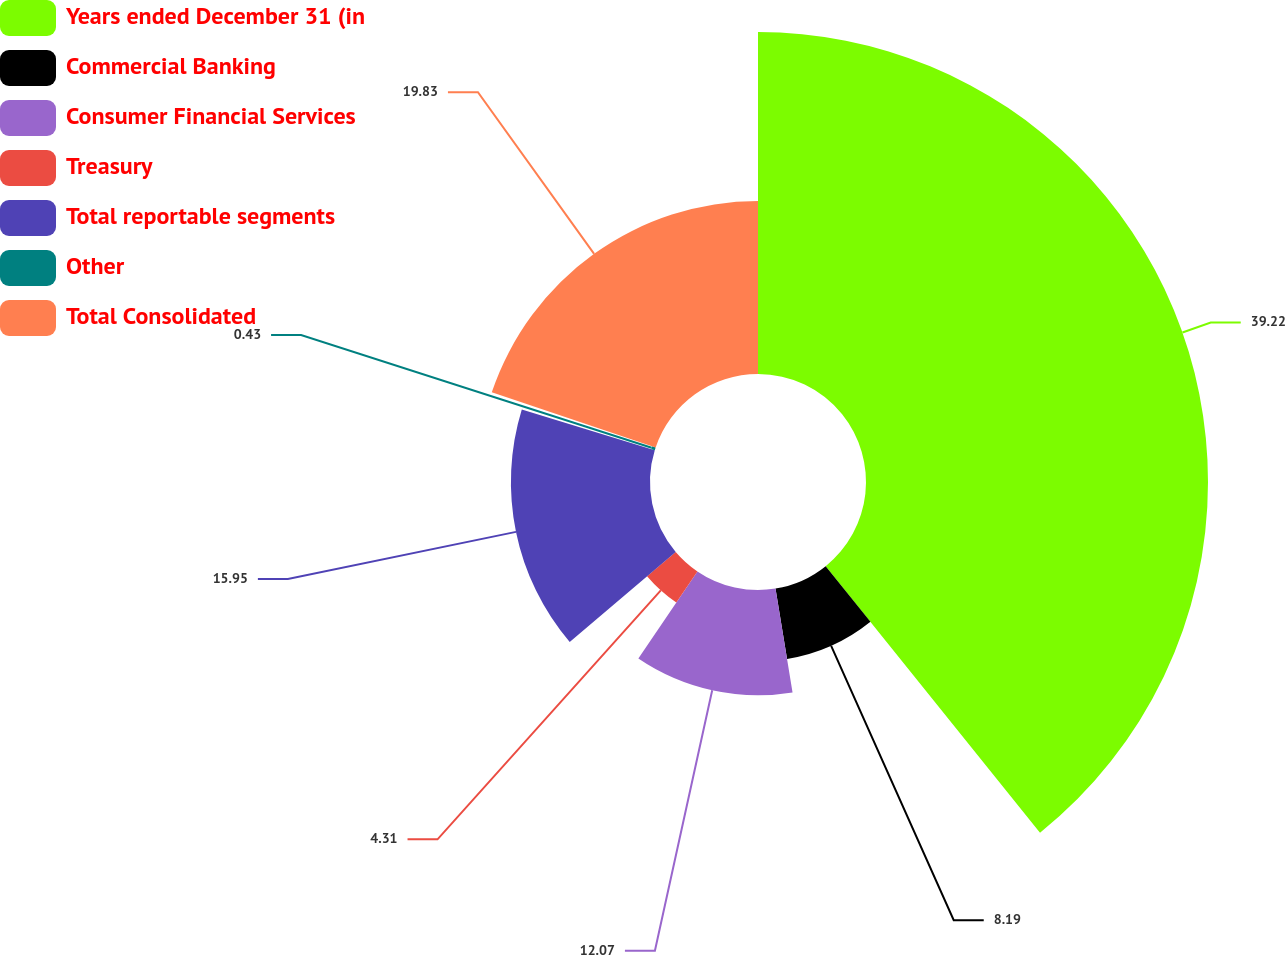Convert chart. <chart><loc_0><loc_0><loc_500><loc_500><pie_chart><fcel>Years ended December 31 (in<fcel>Commercial Banking<fcel>Consumer Financial Services<fcel>Treasury<fcel>Total reportable segments<fcel>Other<fcel>Total Consolidated<nl><fcel>39.22%<fcel>8.19%<fcel>12.07%<fcel>4.31%<fcel>15.95%<fcel>0.43%<fcel>19.83%<nl></chart> 